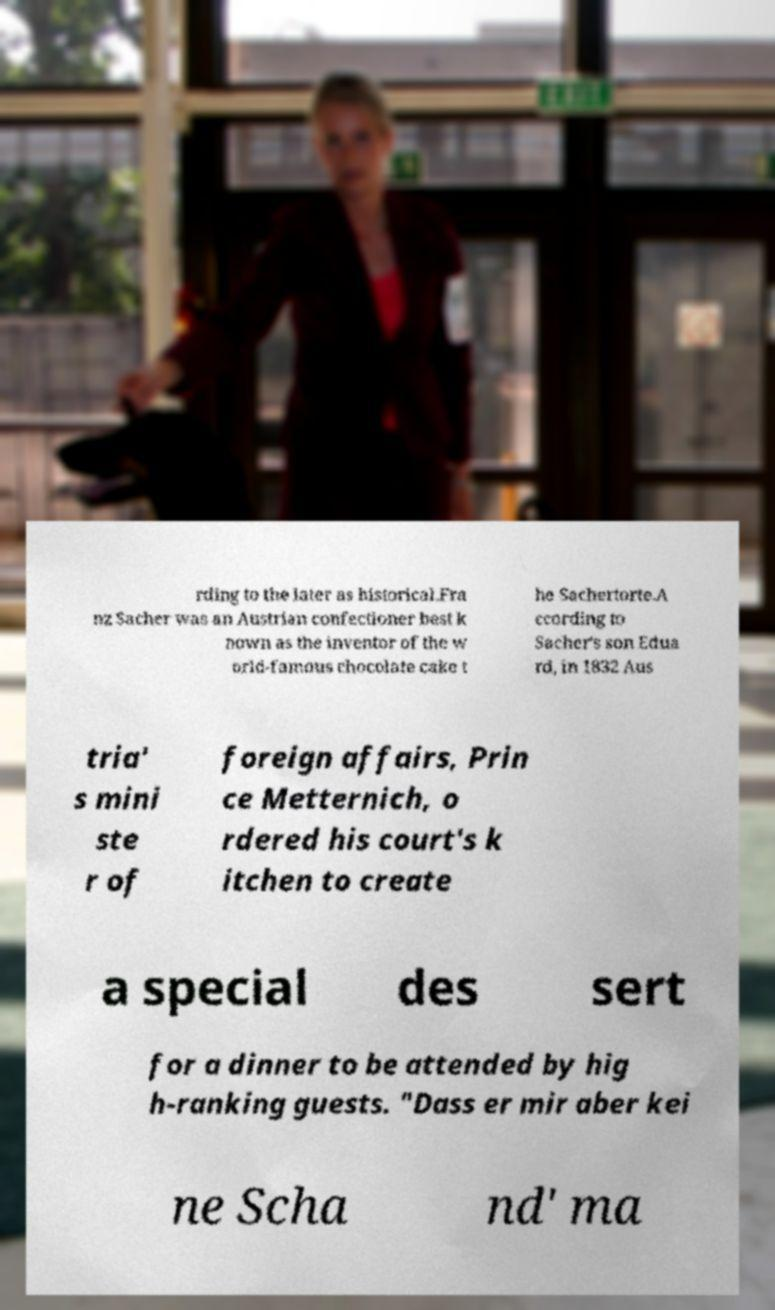What messages or text are displayed in this image? I need them in a readable, typed format. rding to the later as historical.Fra nz Sacher was an Austrian confectioner best k nown as the inventor of the w orld-famous chocolate cake t he Sachertorte.A ccording to Sacher's son Edua rd, in 1832 Aus tria' s mini ste r of foreign affairs, Prin ce Metternich, o rdered his court's k itchen to create a special des sert for a dinner to be attended by hig h-ranking guests. "Dass er mir aber kei ne Scha nd' ma 